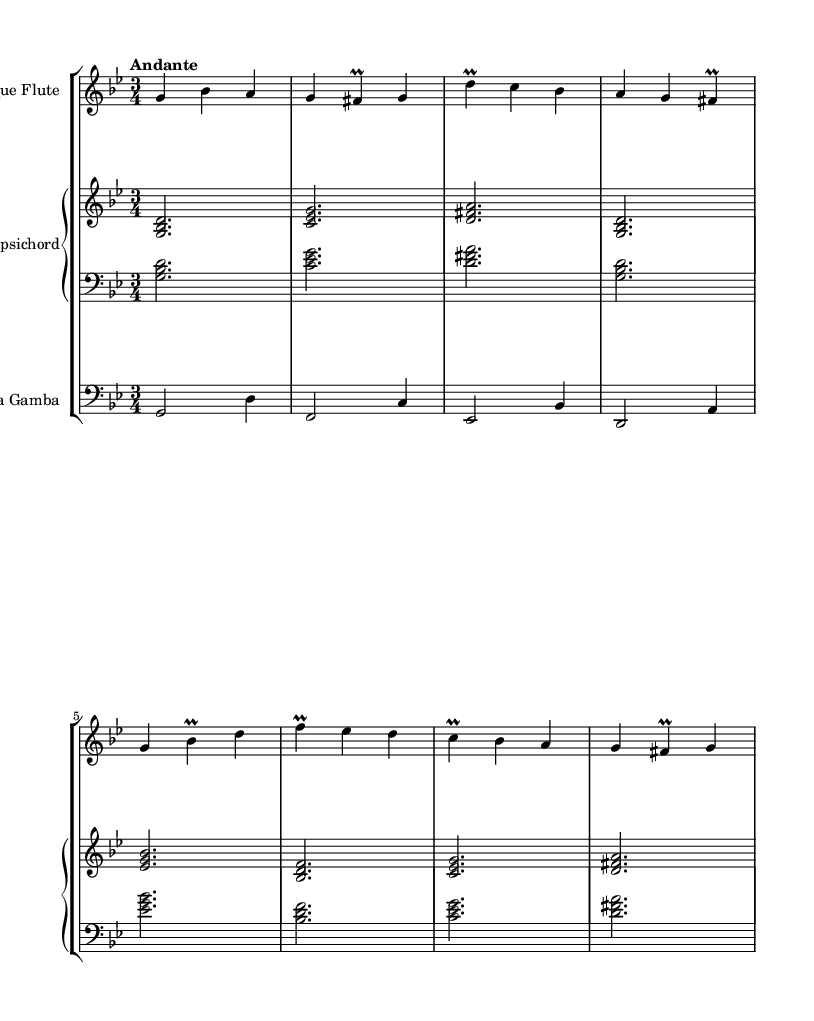What is the key signature of this music? The key signature indicates G minor, which has two flats (B flat and E flat). This can be confirmed by looking at the key signature notation at the beginning of the score.
Answer: G minor What is the time signature of this music? The time signature is 3/4, which is shown at the beginning of the score. This means there are three beats in each measure, and the quarter note gets one beat.
Answer: 3/4 What is the tempo marking? The tempo marking is "Andante", which is indicated at the beginning of the score. This indicates a moderately slow tempo, typically associated with a walking pace.
Answer: Andante How many instruments are in the score? The score consists of three instruments: a Baroque Flute, a Harpsichord (which includes two staves for right and left hands), and a Viola da Gamba. This can be seen from the StaffGroup layout at the beginning of the score.
Answer: Three Which instrument plays the melody predominantly? The Baroque Flute plays the melody predominantly, as it is the only instrument with a distinct melodic line featured in the upper stave. This can be ascertained by observing the flute’s notes and their placement.
Answer: Baroque Flute What is the range of the Viola da Gamba in this piece? The range of the Viola da Gamba extends from G to D, reflecting the notes shown in the bass clef for the Viola staff. This is indicated by the notes present within its staff, where the lowest note is a G and the highest is a D.
Answer: G to D What type of ornamentation is used in the flute part? The flute part frequently employs trills, specifically noted as “prall” symbols. This typically indicates a rapid alternation between the written note and the note above it. This can be observed at several instances in the flute’s melodic line.
Answer: Trills 